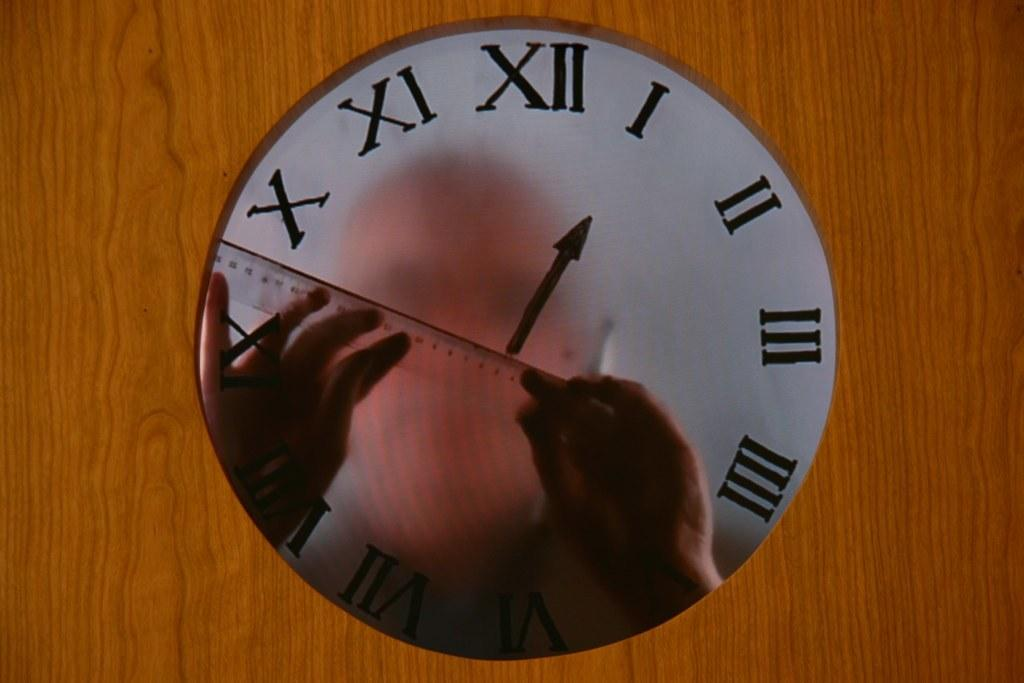<image>
Create a compact narrative representing the image presented. A man's reflection is displayed on a clock with the hand on I 